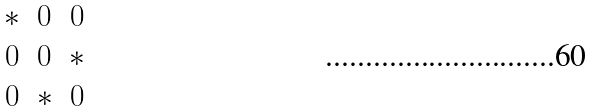<formula> <loc_0><loc_0><loc_500><loc_500>\begin{matrix} * & 0 & 0 \\ 0 & 0 & * \\ 0 & * & 0 \end{matrix}</formula> 